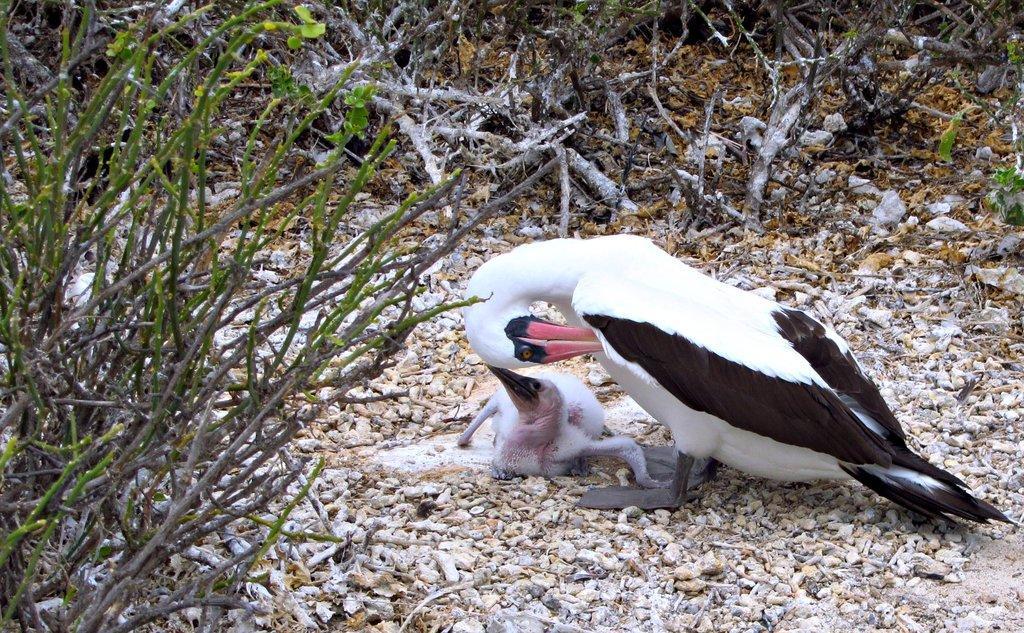Please provide a concise description of this image. In this picture, it seems like a dusk and duckling on the stones in the foreground area of the image, there are plants on the left side and in the background. 